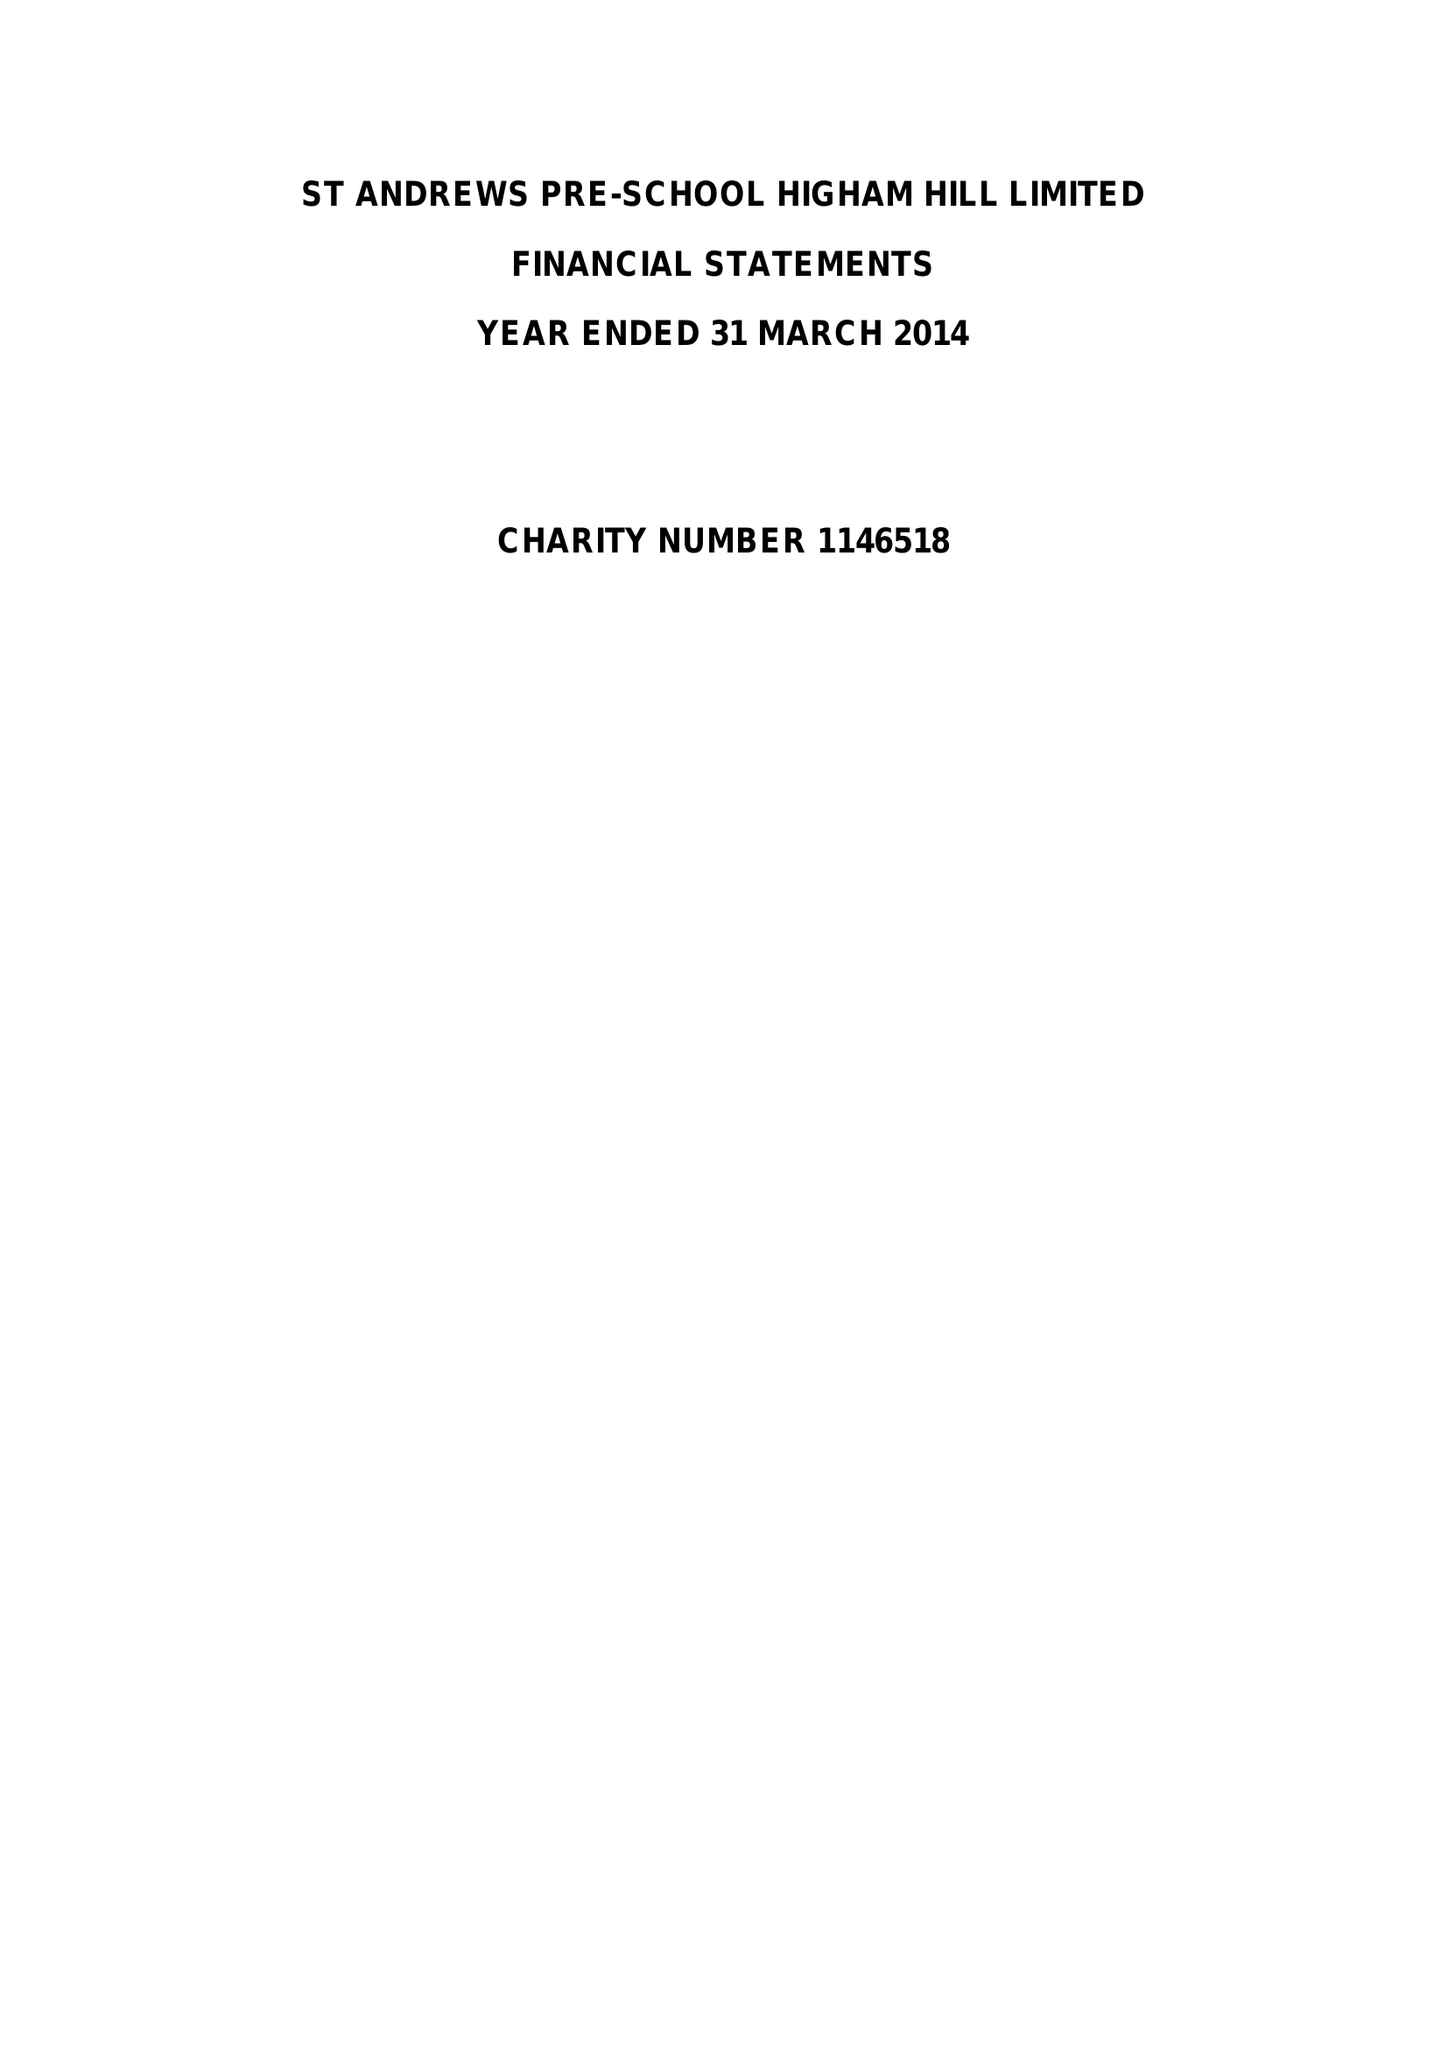What is the value for the address__street_line?
Answer the question using a single word or phrase. CHURCH ROAD 